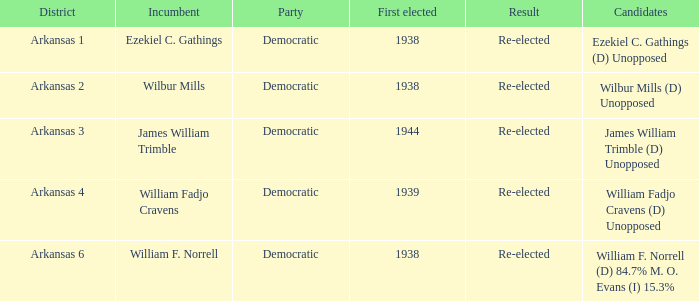In how many districts was william f. norrell the current representative? 1.0. 